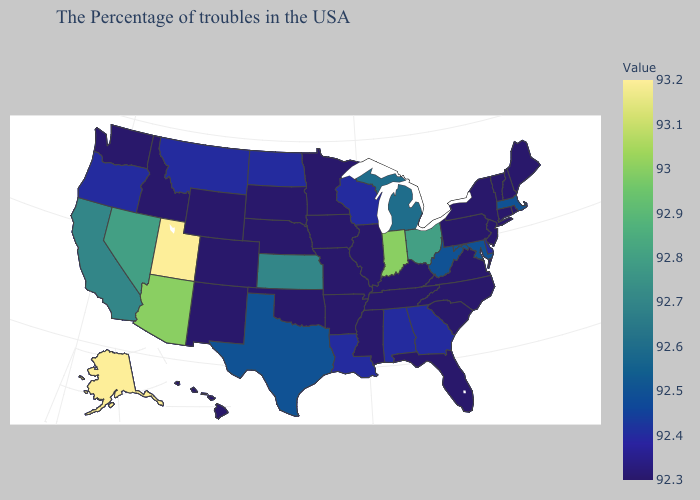Does Oregon have the highest value in the USA?
Be succinct. No. Among the states that border Maine , which have the lowest value?
Answer briefly. New Hampshire. Does Alaska have the lowest value in the USA?
Give a very brief answer. No. Does Utah have the highest value in the USA?
Concise answer only. Yes. Does New Mexico have the lowest value in the West?
Answer briefly. Yes. Which states have the lowest value in the West?
Write a very short answer. Wyoming, Colorado, New Mexico, Idaho, Washington, Hawaii. Among the states that border Indiana , does Kentucky have the lowest value?
Short answer required. Yes. Does Nevada have a lower value than Utah?
Short answer required. Yes. Among the states that border Michigan , does Wisconsin have the highest value?
Short answer required. No. 